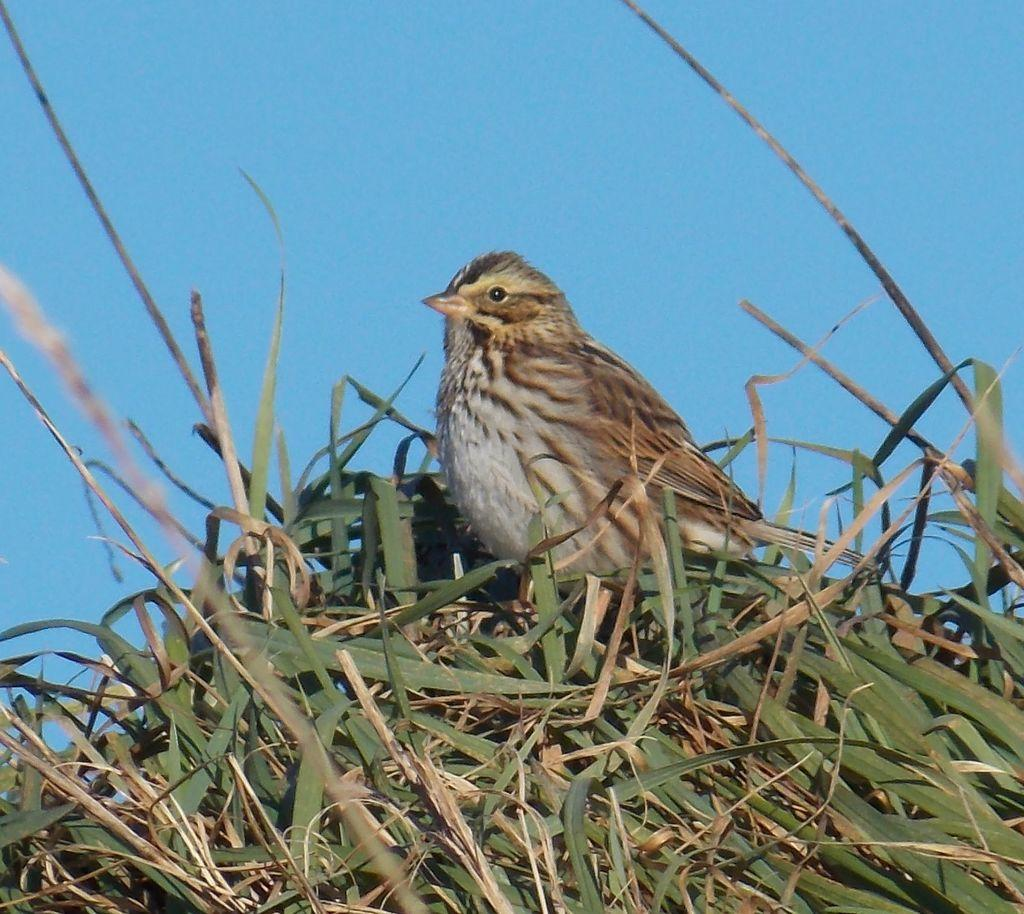What type of animal can be seen in the image? There is a bird in the image. Where is the bird located? The bird is on the grass. What can be seen in the background of the image? The sky is visible in the background of the image. What is the color of the sky? The color of the sky is blue. How long does the bird's trip take in the image? There is no trip or movement of the bird in the image, so it's not possible to determine the duration of a trip. 